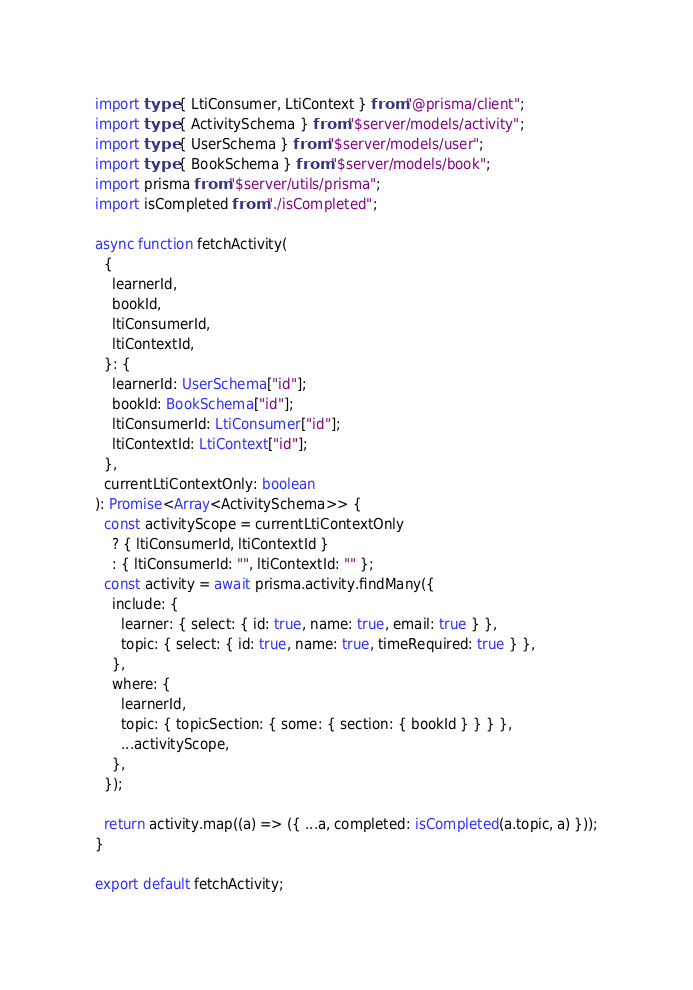Convert code to text. <code><loc_0><loc_0><loc_500><loc_500><_TypeScript_>import type { LtiConsumer, LtiContext } from "@prisma/client";
import type { ActivitySchema } from "$server/models/activity";
import type { UserSchema } from "$server/models/user";
import type { BookSchema } from "$server/models/book";
import prisma from "$server/utils/prisma";
import isCompleted from "./isCompleted";

async function fetchActivity(
  {
    learnerId,
    bookId,
    ltiConsumerId,
    ltiContextId,
  }: {
    learnerId: UserSchema["id"];
    bookId: BookSchema["id"];
    ltiConsumerId: LtiConsumer["id"];
    ltiContextId: LtiContext["id"];
  },
  currentLtiContextOnly: boolean
): Promise<Array<ActivitySchema>> {
  const activityScope = currentLtiContextOnly
    ? { ltiConsumerId, ltiContextId }
    : { ltiConsumerId: "", ltiContextId: "" };
  const activity = await prisma.activity.findMany({
    include: {
      learner: { select: { id: true, name: true, email: true } },
      topic: { select: { id: true, name: true, timeRequired: true } },
    },
    where: {
      learnerId,
      topic: { topicSection: { some: { section: { bookId } } } },
      ...activityScope,
    },
  });

  return activity.map((a) => ({ ...a, completed: isCompleted(a.topic, a) }));
}

export default fetchActivity;
</code> 